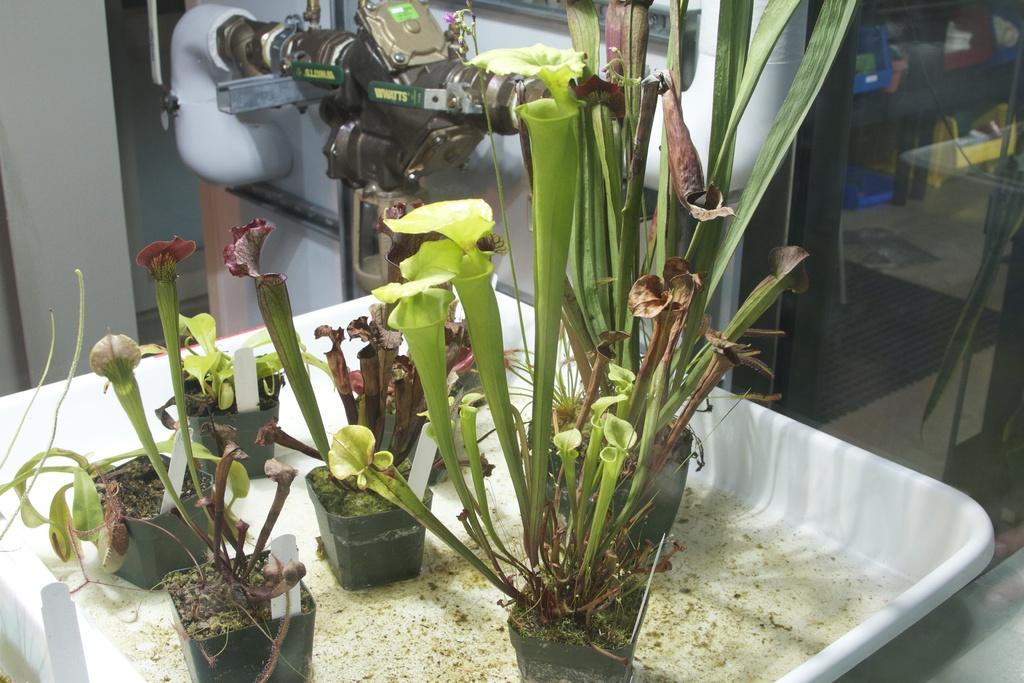Can you describe this image briefly? In this image I can see few plants in the tray and the plants are in green color and the tray is in white color. Background I can see a glass wall and I can see a machine in gray color. 